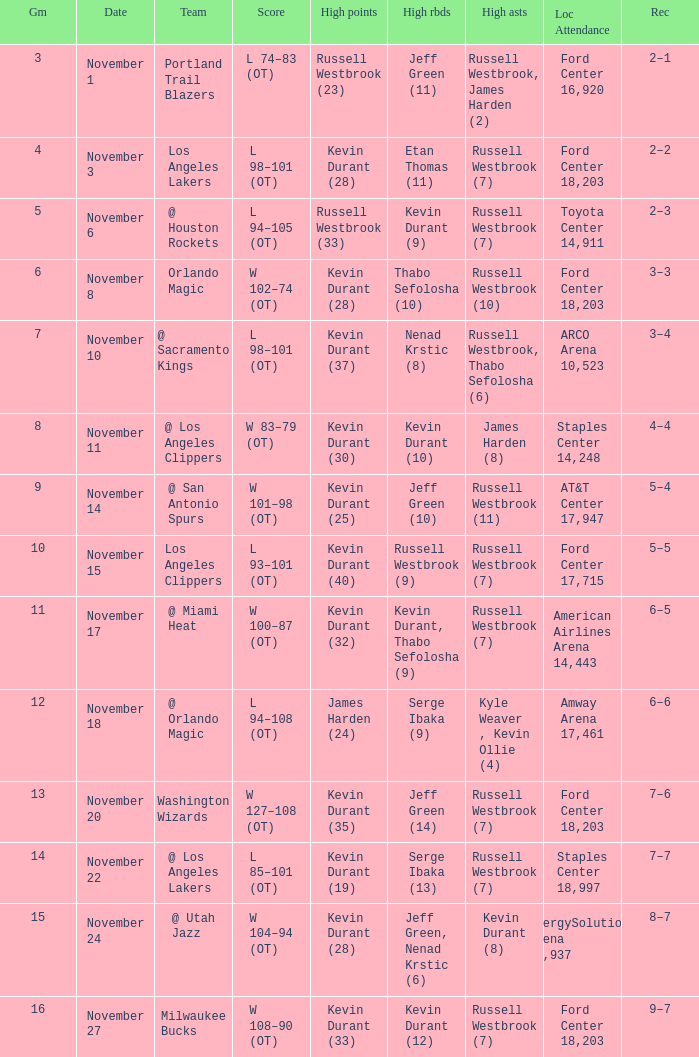Where was the game in which Kevin Durant (25) did the most high points played? AT&T Center 17,947. 